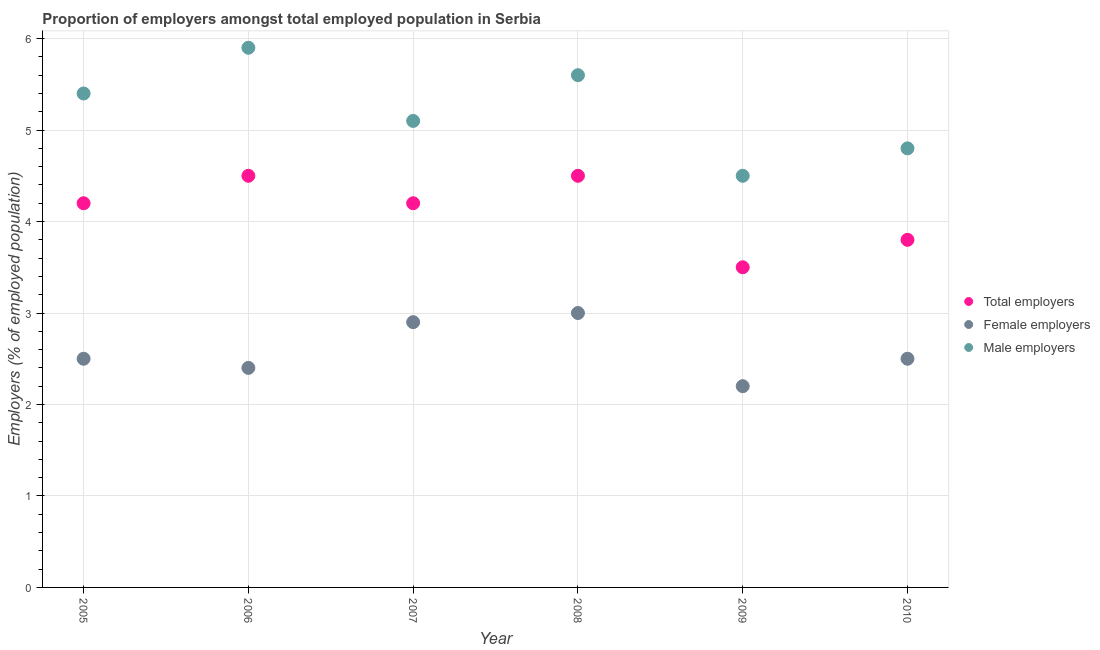Is the number of dotlines equal to the number of legend labels?
Keep it short and to the point. Yes. What is the percentage of female employers in 2009?
Make the answer very short. 2.2. Across all years, what is the minimum percentage of male employers?
Keep it short and to the point. 4.5. In which year was the percentage of female employers minimum?
Give a very brief answer. 2009. What is the total percentage of total employers in the graph?
Your answer should be very brief. 24.7. What is the difference between the percentage of female employers in 2005 and that in 2008?
Keep it short and to the point. -0.5. What is the difference between the percentage of total employers in 2007 and the percentage of male employers in 2008?
Give a very brief answer. -1.4. What is the average percentage of total employers per year?
Your answer should be compact. 4.12. In the year 2009, what is the difference between the percentage of female employers and percentage of male employers?
Keep it short and to the point. -2.3. In how many years, is the percentage of male employers greater than 5.6 %?
Make the answer very short. 1. What is the ratio of the percentage of female employers in 2005 to that in 2008?
Offer a very short reply. 0.83. Is the percentage of total employers in 2005 less than that in 2007?
Provide a short and direct response. No. Is the difference between the percentage of female employers in 2006 and 2007 greater than the difference between the percentage of total employers in 2006 and 2007?
Offer a very short reply. No. What is the difference between the highest and the second highest percentage of female employers?
Offer a very short reply. 0.1. What is the difference between the highest and the lowest percentage of female employers?
Offer a terse response. 0.8. Does the percentage of male employers monotonically increase over the years?
Your answer should be very brief. No. How many dotlines are there?
Offer a very short reply. 3. What is the difference between two consecutive major ticks on the Y-axis?
Offer a terse response. 1. Where does the legend appear in the graph?
Provide a succinct answer. Center right. How are the legend labels stacked?
Ensure brevity in your answer.  Vertical. What is the title of the graph?
Your answer should be very brief. Proportion of employers amongst total employed population in Serbia. What is the label or title of the Y-axis?
Offer a very short reply. Employers (% of employed population). What is the Employers (% of employed population) in Total employers in 2005?
Your response must be concise. 4.2. What is the Employers (% of employed population) in Female employers in 2005?
Ensure brevity in your answer.  2.5. What is the Employers (% of employed population) of Male employers in 2005?
Your answer should be very brief. 5.4. What is the Employers (% of employed population) of Female employers in 2006?
Keep it short and to the point. 2.4. What is the Employers (% of employed population) of Male employers in 2006?
Ensure brevity in your answer.  5.9. What is the Employers (% of employed population) in Total employers in 2007?
Give a very brief answer. 4.2. What is the Employers (% of employed population) in Female employers in 2007?
Provide a short and direct response. 2.9. What is the Employers (% of employed population) of Male employers in 2007?
Give a very brief answer. 5.1. What is the Employers (% of employed population) in Female employers in 2008?
Keep it short and to the point. 3. What is the Employers (% of employed population) of Male employers in 2008?
Give a very brief answer. 5.6. What is the Employers (% of employed population) in Female employers in 2009?
Offer a terse response. 2.2. What is the Employers (% of employed population) in Total employers in 2010?
Your response must be concise. 3.8. What is the Employers (% of employed population) in Female employers in 2010?
Offer a very short reply. 2.5. What is the Employers (% of employed population) of Male employers in 2010?
Your response must be concise. 4.8. Across all years, what is the maximum Employers (% of employed population) of Total employers?
Make the answer very short. 4.5. Across all years, what is the maximum Employers (% of employed population) of Female employers?
Provide a succinct answer. 3. Across all years, what is the maximum Employers (% of employed population) in Male employers?
Provide a short and direct response. 5.9. Across all years, what is the minimum Employers (% of employed population) in Female employers?
Your answer should be very brief. 2.2. What is the total Employers (% of employed population) of Total employers in the graph?
Provide a short and direct response. 24.7. What is the total Employers (% of employed population) of Male employers in the graph?
Ensure brevity in your answer.  31.3. What is the difference between the Employers (% of employed population) of Total employers in 2005 and that in 2006?
Your response must be concise. -0.3. What is the difference between the Employers (% of employed population) in Male employers in 2005 and that in 2006?
Give a very brief answer. -0.5. What is the difference between the Employers (% of employed population) of Total employers in 2005 and that in 2007?
Make the answer very short. 0. What is the difference between the Employers (% of employed population) of Total employers in 2005 and that in 2009?
Make the answer very short. 0.7. What is the difference between the Employers (% of employed population) of Female employers in 2005 and that in 2009?
Provide a succinct answer. 0.3. What is the difference between the Employers (% of employed population) in Female employers in 2006 and that in 2007?
Make the answer very short. -0.5. What is the difference between the Employers (% of employed population) in Female employers in 2006 and that in 2008?
Offer a terse response. -0.6. What is the difference between the Employers (% of employed population) in Male employers in 2006 and that in 2010?
Your response must be concise. 1.1. What is the difference between the Employers (% of employed population) of Total employers in 2007 and that in 2008?
Your response must be concise. -0.3. What is the difference between the Employers (% of employed population) of Female employers in 2007 and that in 2008?
Offer a very short reply. -0.1. What is the difference between the Employers (% of employed population) in Male employers in 2007 and that in 2008?
Your response must be concise. -0.5. What is the difference between the Employers (% of employed population) in Female employers in 2007 and that in 2009?
Keep it short and to the point. 0.7. What is the difference between the Employers (% of employed population) in Male employers in 2007 and that in 2009?
Provide a succinct answer. 0.6. What is the difference between the Employers (% of employed population) in Total employers in 2007 and that in 2010?
Your answer should be compact. 0.4. What is the difference between the Employers (% of employed population) in Male employers in 2007 and that in 2010?
Your answer should be compact. 0.3. What is the difference between the Employers (% of employed population) of Total employers in 2008 and that in 2009?
Provide a short and direct response. 1. What is the difference between the Employers (% of employed population) of Female employers in 2008 and that in 2009?
Your answer should be compact. 0.8. What is the difference between the Employers (% of employed population) in Total employers in 2008 and that in 2010?
Your response must be concise. 0.7. What is the difference between the Employers (% of employed population) of Total employers in 2005 and the Employers (% of employed population) of Female employers in 2006?
Give a very brief answer. 1.8. What is the difference between the Employers (% of employed population) in Female employers in 2005 and the Employers (% of employed population) in Male employers in 2006?
Offer a very short reply. -3.4. What is the difference between the Employers (% of employed population) in Total employers in 2005 and the Employers (% of employed population) in Female employers in 2007?
Provide a short and direct response. 1.3. What is the difference between the Employers (% of employed population) of Total employers in 2005 and the Employers (% of employed population) of Male employers in 2007?
Keep it short and to the point. -0.9. What is the difference between the Employers (% of employed population) in Female employers in 2005 and the Employers (% of employed population) in Male employers in 2007?
Make the answer very short. -2.6. What is the difference between the Employers (% of employed population) in Total employers in 2005 and the Employers (% of employed population) in Female employers in 2008?
Your answer should be compact. 1.2. What is the difference between the Employers (% of employed population) in Total employers in 2005 and the Employers (% of employed population) in Male employers in 2008?
Provide a short and direct response. -1.4. What is the difference between the Employers (% of employed population) of Female employers in 2005 and the Employers (% of employed population) of Male employers in 2008?
Provide a succinct answer. -3.1. What is the difference between the Employers (% of employed population) in Total employers in 2005 and the Employers (% of employed population) in Male employers in 2009?
Provide a short and direct response. -0.3. What is the difference between the Employers (% of employed population) of Female employers in 2005 and the Employers (% of employed population) of Male employers in 2009?
Give a very brief answer. -2. What is the difference between the Employers (% of employed population) of Total employers in 2005 and the Employers (% of employed population) of Male employers in 2010?
Offer a very short reply. -0.6. What is the difference between the Employers (% of employed population) in Female employers in 2005 and the Employers (% of employed population) in Male employers in 2010?
Provide a short and direct response. -2.3. What is the difference between the Employers (% of employed population) of Female employers in 2006 and the Employers (% of employed population) of Male employers in 2007?
Give a very brief answer. -2.7. What is the difference between the Employers (% of employed population) in Female employers in 2006 and the Employers (% of employed population) in Male employers in 2008?
Provide a succinct answer. -3.2. What is the difference between the Employers (% of employed population) in Female employers in 2006 and the Employers (% of employed population) in Male employers in 2009?
Keep it short and to the point. -2.1. What is the difference between the Employers (% of employed population) in Total employers in 2007 and the Employers (% of employed population) in Male employers in 2008?
Provide a short and direct response. -1.4. What is the difference between the Employers (% of employed population) of Female employers in 2007 and the Employers (% of employed population) of Male employers in 2008?
Give a very brief answer. -2.7. What is the difference between the Employers (% of employed population) in Total employers in 2007 and the Employers (% of employed population) in Male employers in 2009?
Provide a short and direct response. -0.3. What is the difference between the Employers (% of employed population) of Female employers in 2007 and the Employers (% of employed population) of Male employers in 2009?
Provide a succinct answer. -1.6. What is the difference between the Employers (% of employed population) of Total employers in 2007 and the Employers (% of employed population) of Female employers in 2010?
Your answer should be very brief. 1.7. What is the difference between the Employers (% of employed population) of Total employers in 2008 and the Employers (% of employed population) of Female employers in 2009?
Keep it short and to the point. 2.3. What is the difference between the Employers (% of employed population) in Female employers in 2008 and the Employers (% of employed population) in Male employers in 2009?
Offer a very short reply. -1.5. What is the difference between the Employers (% of employed population) of Total employers in 2008 and the Employers (% of employed population) of Female employers in 2010?
Offer a terse response. 2. What is the difference between the Employers (% of employed population) in Total employers in 2008 and the Employers (% of employed population) in Male employers in 2010?
Provide a succinct answer. -0.3. What is the difference between the Employers (% of employed population) in Female employers in 2009 and the Employers (% of employed population) in Male employers in 2010?
Make the answer very short. -2.6. What is the average Employers (% of employed population) of Total employers per year?
Your response must be concise. 4.12. What is the average Employers (% of employed population) in Female employers per year?
Your response must be concise. 2.58. What is the average Employers (% of employed population) in Male employers per year?
Provide a short and direct response. 5.22. In the year 2005, what is the difference between the Employers (% of employed population) of Total employers and Employers (% of employed population) of Female employers?
Offer a terse response. 1.7. In the year 2005, what is the difference between the Employers (% of employed population) in Total employers and Employers (% of employed population) in Male employers?
Your answer should be compact. -1.2. In the year 2005, what is the difference between the Employers (% of employed population) in Female employers and Employers (% of employed population) in Male employers?
Provide a short and direct response. -2.9. In the year 2006, what is the difference between the Employers (% of employed population) of Total employers and Employers (% of employed population) of Female employers?
Provide a succinct answer. 2.1. In the year 2006, what is the difference between the Employers (% of employed population) in Female employers and Employers (% of employed population) in Male employers?
Your answer should be very brief. -3.5. In the year 2007, what is the difference between the Employers (% of employed population) of Total employers and Employers (% of employed population) of Female employers?
Provide a succinct answer. 1.3. In the year 2007, what is the difference between the Employers (% of employed population) of Total employers and Employers (% of employed population) of Male employers?
Provide a succinct answer. -0.9. In the year 2008, what is the difference between the Employers (% of employed population) in Total employers and Employers (% of employed population) in Female employers?
Provide a succinct answer. 1.5. In the year 2008, what is the difference between the Employers (% of employed population) in Total employers and Employers (% of employed population) in Male employers?
Give a very brief answer. -1.1. In the year 2009, what is the difference between the Employers (% of employed population) of Total employers and Employers (% of employed population) of Female employers?
Offer a very short reply. 1.3. In the year 2009, what is the difference between the Employers (% of employed population) in Female employers and Employers (% of employed population) in Male employers?
Make the answer very short. -2.3. In the year 2010, what is the difference between the Employers (% of employed population) in Total employers and Employers (% of employed population) in Female employers?
Offer a terse response. 1.3. In the year 2010, what is the difference between the Employers (% of employed population) of Total employers and Employers (% of employed population) of Male employers?
Provide a short and direct response. -1. What is the ratio of the Employers (% of employed population) in Total employers in 2005 to that in 2006?
Provide a short and direct response. 0.93. What is the ratio of the Employers (% of employed population) of Female employers in 2005 to that in 2006?
Offer a very short reply. 1.04. What is the ratio of the Employers (% of employed population) in Male employers in 2005 to that in 2006?
Give a very brief answer. 0.92. What is the ratio of the Employers (% of employed population) of Female employers in 2005 to that in 2007?
Keep it short and to the point. 0.86. What is the ratio of the Employers (% of employed population) of Male employers in 2005 to that in 2007?
Offer a terse response. 1.06. What is the ratio of the Employers (% of employed population) of Total employers in 2005 to that in 2008?
Keep it short and to the point. 0.93. What is the ratio of the Employers (% of employed population) of Female employers in 2005 to that in 2008?
Provide a succinct answer. 0.83. What is the ratio of the Employers (% of employed population) of Female employers in 2005 to that in 2009?
Offer a very short reply. 1.14. What is the ratio of the Employers (% of employed population) in Male employers in 2005 to that in 2009?
Ensure brevity in your answer.  1.2. What is the ratio of the Employers (% of employed population) of Total employers in 2005 to that in 2010?
Your answer should be very brief. 1.11. What is the ratio of the Employers (% of employed population) of Total employers in 2006 to that in 2007?
Your response must be concise. 1.07. What is the ratio of the Employers (% of employed population) of Female employers in 2006 to that in 2007?
Ensure brevity in your answer.  0.83. What is the ratio of the Employers (% of employed population) of Male employers in 2006 to that in 2007?
Provide a short and direct response. 1.16. What is the ratio of the Employers (% of employed population) in Male employers in 2006 to that in 2008?
Make the answer very short. 1.05. What is the ratio of the Employers (% of employed population) of Total employers in 2006 to that in 2009?
Offer a terse response. 1.29. What is the ratio of the Employers (% of employed population) of Female employers in 2006 to that in 2009?
Offer a very short reply. 1.09. What is the ratio of the Employers (% of employed population) of Male employers in 2006 to that in 2009?
Give a very brief answer. 1.31. What is the ratio of the Employers (% of employed population) of Total employers in 2006 to that in 2010?
Ensure brevity in your answer.  1.18. What is the ratio of the Employers (% of employed population) in Female employers in 2006 to that in 2010?
Ensure brevity in your answer.  0.96. What is the ratio of the Employers (% of employed population) in Male employers in 2006 to that in 2010?
Make the answer very short. 1.23. What is the ratio of the Employers (% of employed population) of Female employers in 2007 to that in 2008?
Give a very brief answer. 0.97. What is the ratio of the Employers (% of employed population) in Male employers in 2007 to that in 2008?
Your answer should be compact. 0.91. What is the ratio of the Employers (% of employed population) in Female employers in 2007 to that in 2009?
Offer a very short reply. 1.32. What is the ratio of the Employers (% of employed population) in Male employers in 2007 to that in 2009?
Ensure brevity in your answer.  1.13. What is the ratio of the Employers (% of employed population) in Total employers in 2007 to that in 2010?
Your response must be concise. 1.11. What is the ratio of the Employers (% of employed population) of Female employers in 2007 to that in 2010?
Offer a terse response. 1.16. What is the ratio of the Employers (% of employed population) of Male employers in 2007 to that in 2010?
Provide a succinct answer. 1.06. What is the ratio of the Employers (% of employed population) of Female employers in 2008 to that in 2009?
Give a very brief answer. 1.36. What is the ratio of the Employers (% of employed population) of Male employers in 2008 to that in 2009?
Your response must be concise. 1.24. What is the ratio of the Employers (% of employed population) in Total employers in 2008 to that in 2010?
Make the answer very short. 1.18. What is the ratio of the Employers (% of employed population) in Male employers in 2008 to that in 2010?
Give a very brief answer. 1.17. What is the ratio of the Employers (% of employed population) in Total employers in 2009 to that in 2010?
Provide a short and direct response. 0.92. What is the difference between the highest and the second highest Employers (% of employed population) of Male employers?
Offer a terse response. 0.3. What is the difference between the highest and the lowest Employers (% of employed population) in Total employers?
Your answer should be very brief. 1. What is the difference between the highest and the lowest Employers (% of employed population) in Female employers?
Your answer should be very brief. 0.8. What is the difference between the highest and the lowest Employers (% of employed population) in Male employers?
Give a very brief answer. 1.4. 